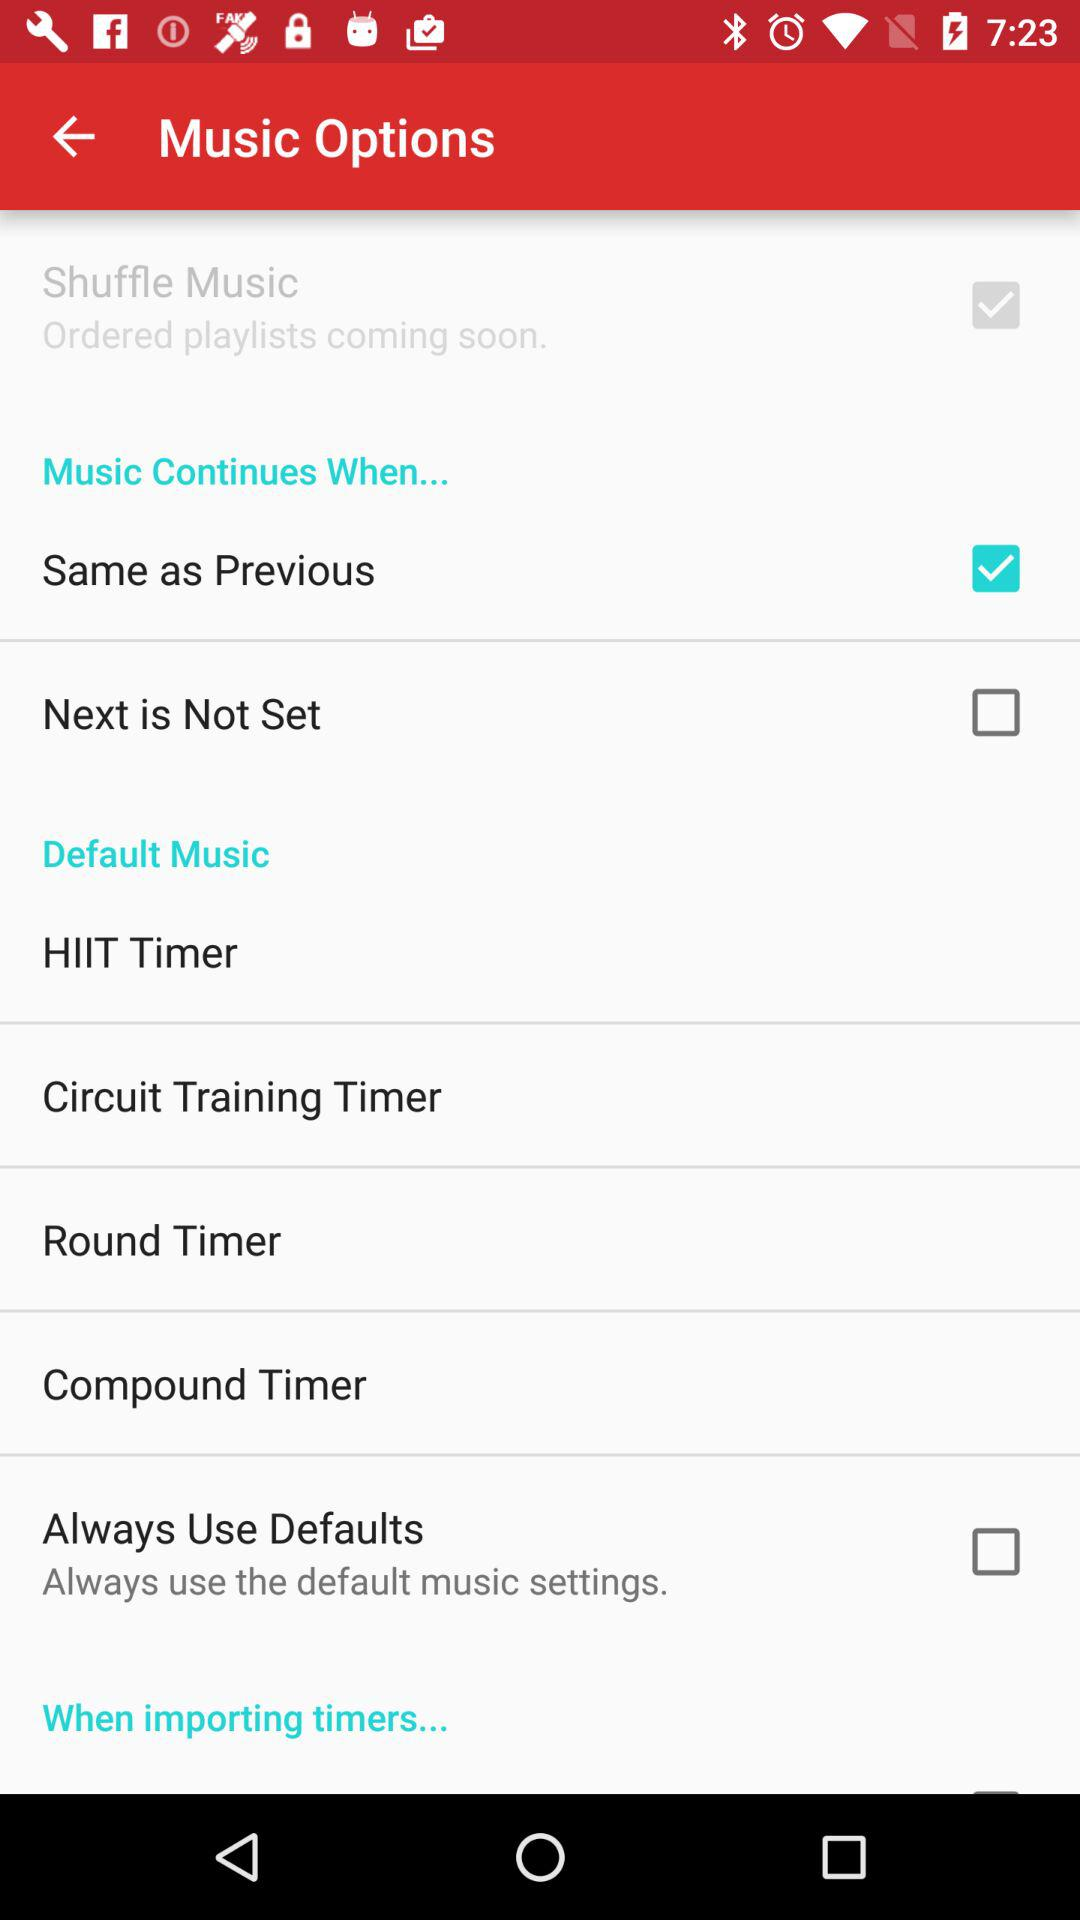How many timers are there in the Default Music section?
Answer the question using a single word or phrase. 4 